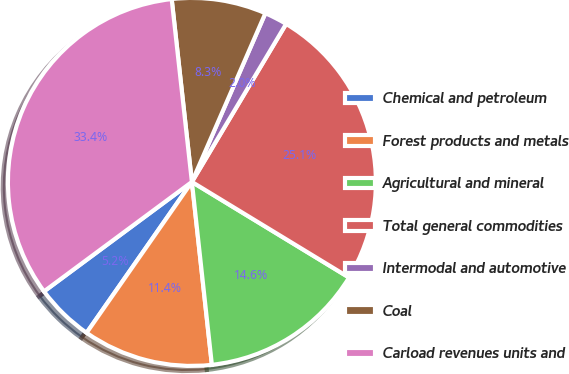Convert chart to OTSL. <chart><loc_0><loc_0><loc_500><loc_500><pie_chart><fcel>Chemical and petroleum<fcel>Forest products and metals<fcel>Agricultural and mineral<fcel>Total general commodities<fcel>Intermodal and automotive<fcel>Coal<fcel>Carload revenues units and<nl><fcel>5.16%<fcel>11.43%<fcel>14.57%<fcel>25.14%<fcel>2.02%<fcel>8.29%<fcel>33.39%<nl></chart> 